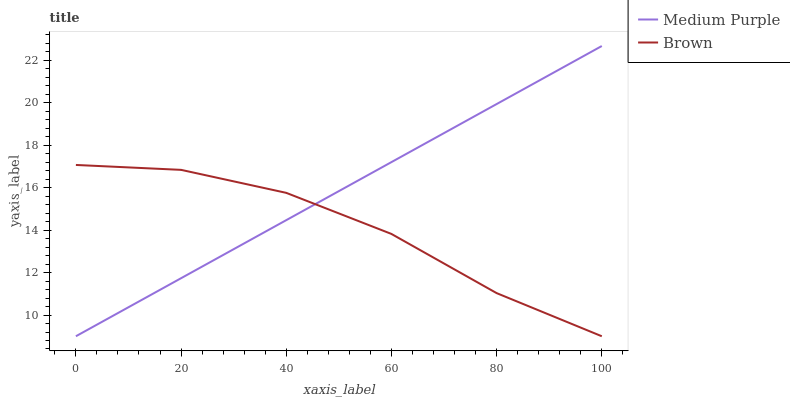Does Brown have the minimum area under the curve?
Answer yes or no. Yes. Does Medium Purple have the maximum area under the curve?
Answer yes or no. Yes. Does Brown have the maximum area under the curve?
Answer yes or no. No. Is Medium Purple the smoothest?
Answer yes or no. Yes. Is Brown the roughest?
Answer yes or no. Yes. Is Brown the smoothest?
Answer yes or no. No. Does Medium Purple have the lowest value?
Answer yes or no. Yes. Does Medium Purple have the highest value?
Answer yes or no. Yes. Does Brown have the highest value?
Answer yes or no. No. Does Brown intersect Medium Purple?
Answer yes or no. Yes. Is Brown less than Medium Purple?
Answer yes or no. No. Is Brown greater than Medium Purple?
Answer yes or no. No. 